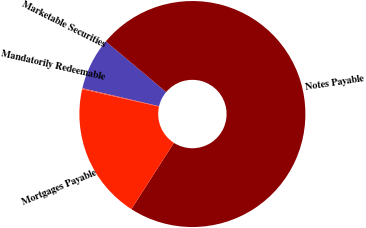Convert chart to OTSL. <chart><loc_0><loc_0><loc_500><loc_500><pie_chart><fcel>Marketable Securities<fcel>Notes Payable<fcel>Mortgages Payable<fcel>Mandatorily Redeemable<nl><fcel>7.44%<fcel>72.97%<fcel>19.44%<fcel>0.15%<nl></chart> 